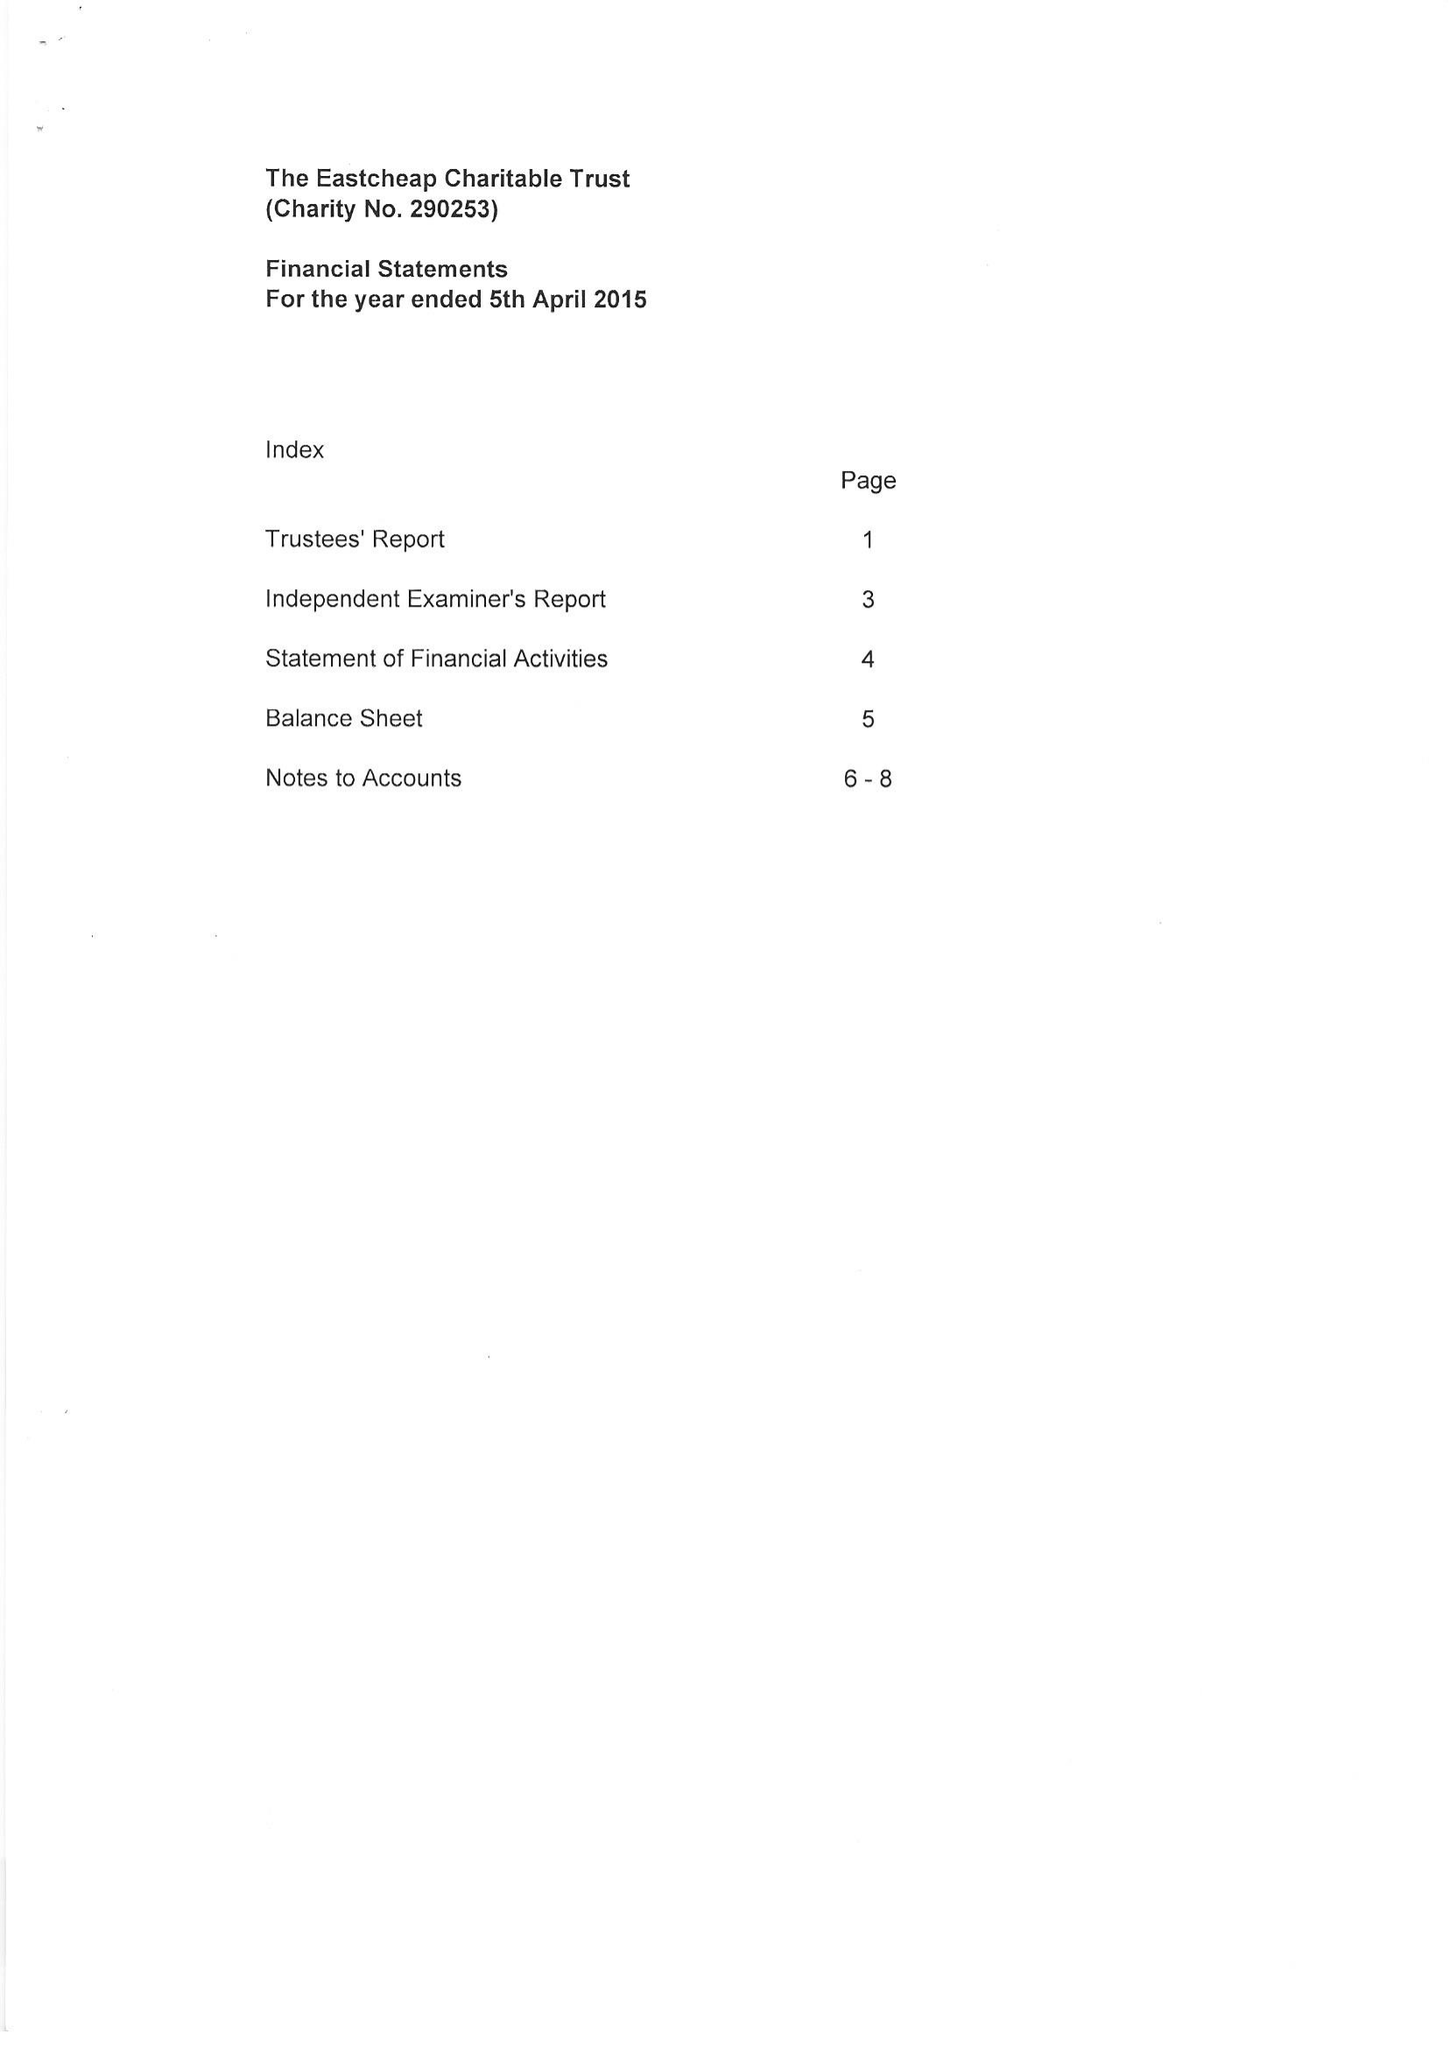What is the value for the report_date?
Answer the question using a single word or phrase. 2015-04-05 